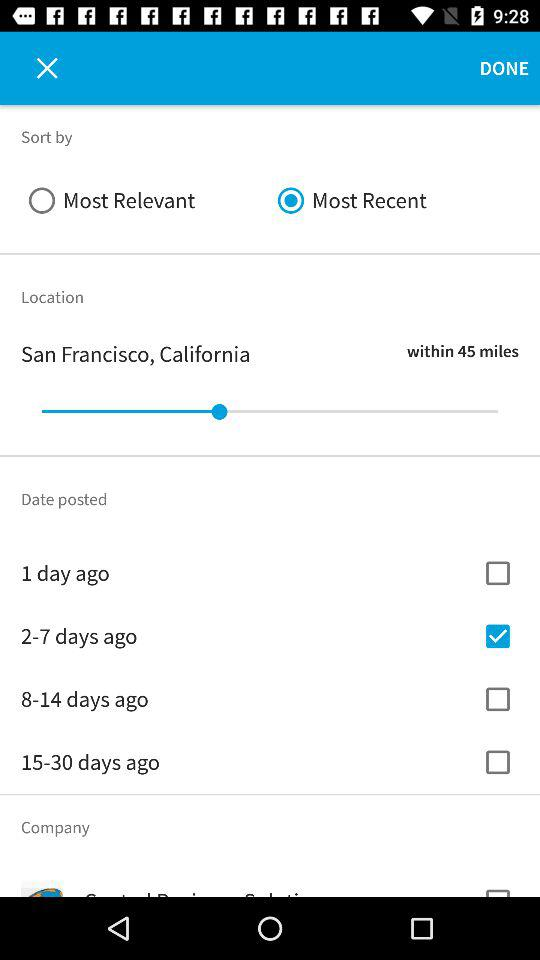How many checkboxes are there for the date posted filter?
Answer the question using a single word or phrase. 4 